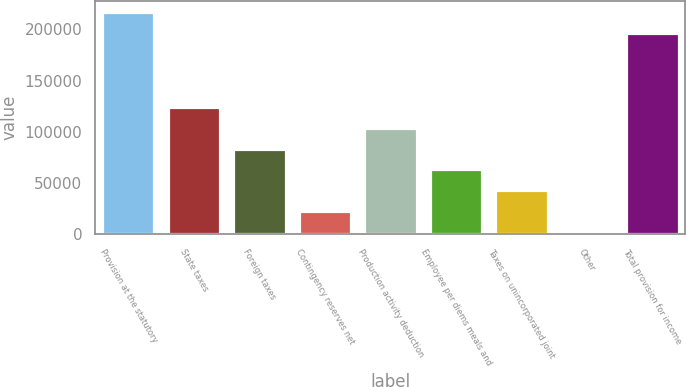<chart> <loc_0><loc_0><loc_500><loc_500><bar_chart><fcel>Provision at the statutory<fcel>State taxes<fcel>Foreign taxes<fcel>Contingency reserves net<fcel>Production activity deduction<fcel>Employee per diems meals and<fcel>Taxes on unincorporated joint<fcel>Other<fcel>Total provision for income<nl><fcel>217238<fcel>124462<fcel>83736.4<fcel>22648.6<fcel>104099<fcel>63373.8<fcel>43011.2<fcel>2286<fcel>196875<nl></chart> 